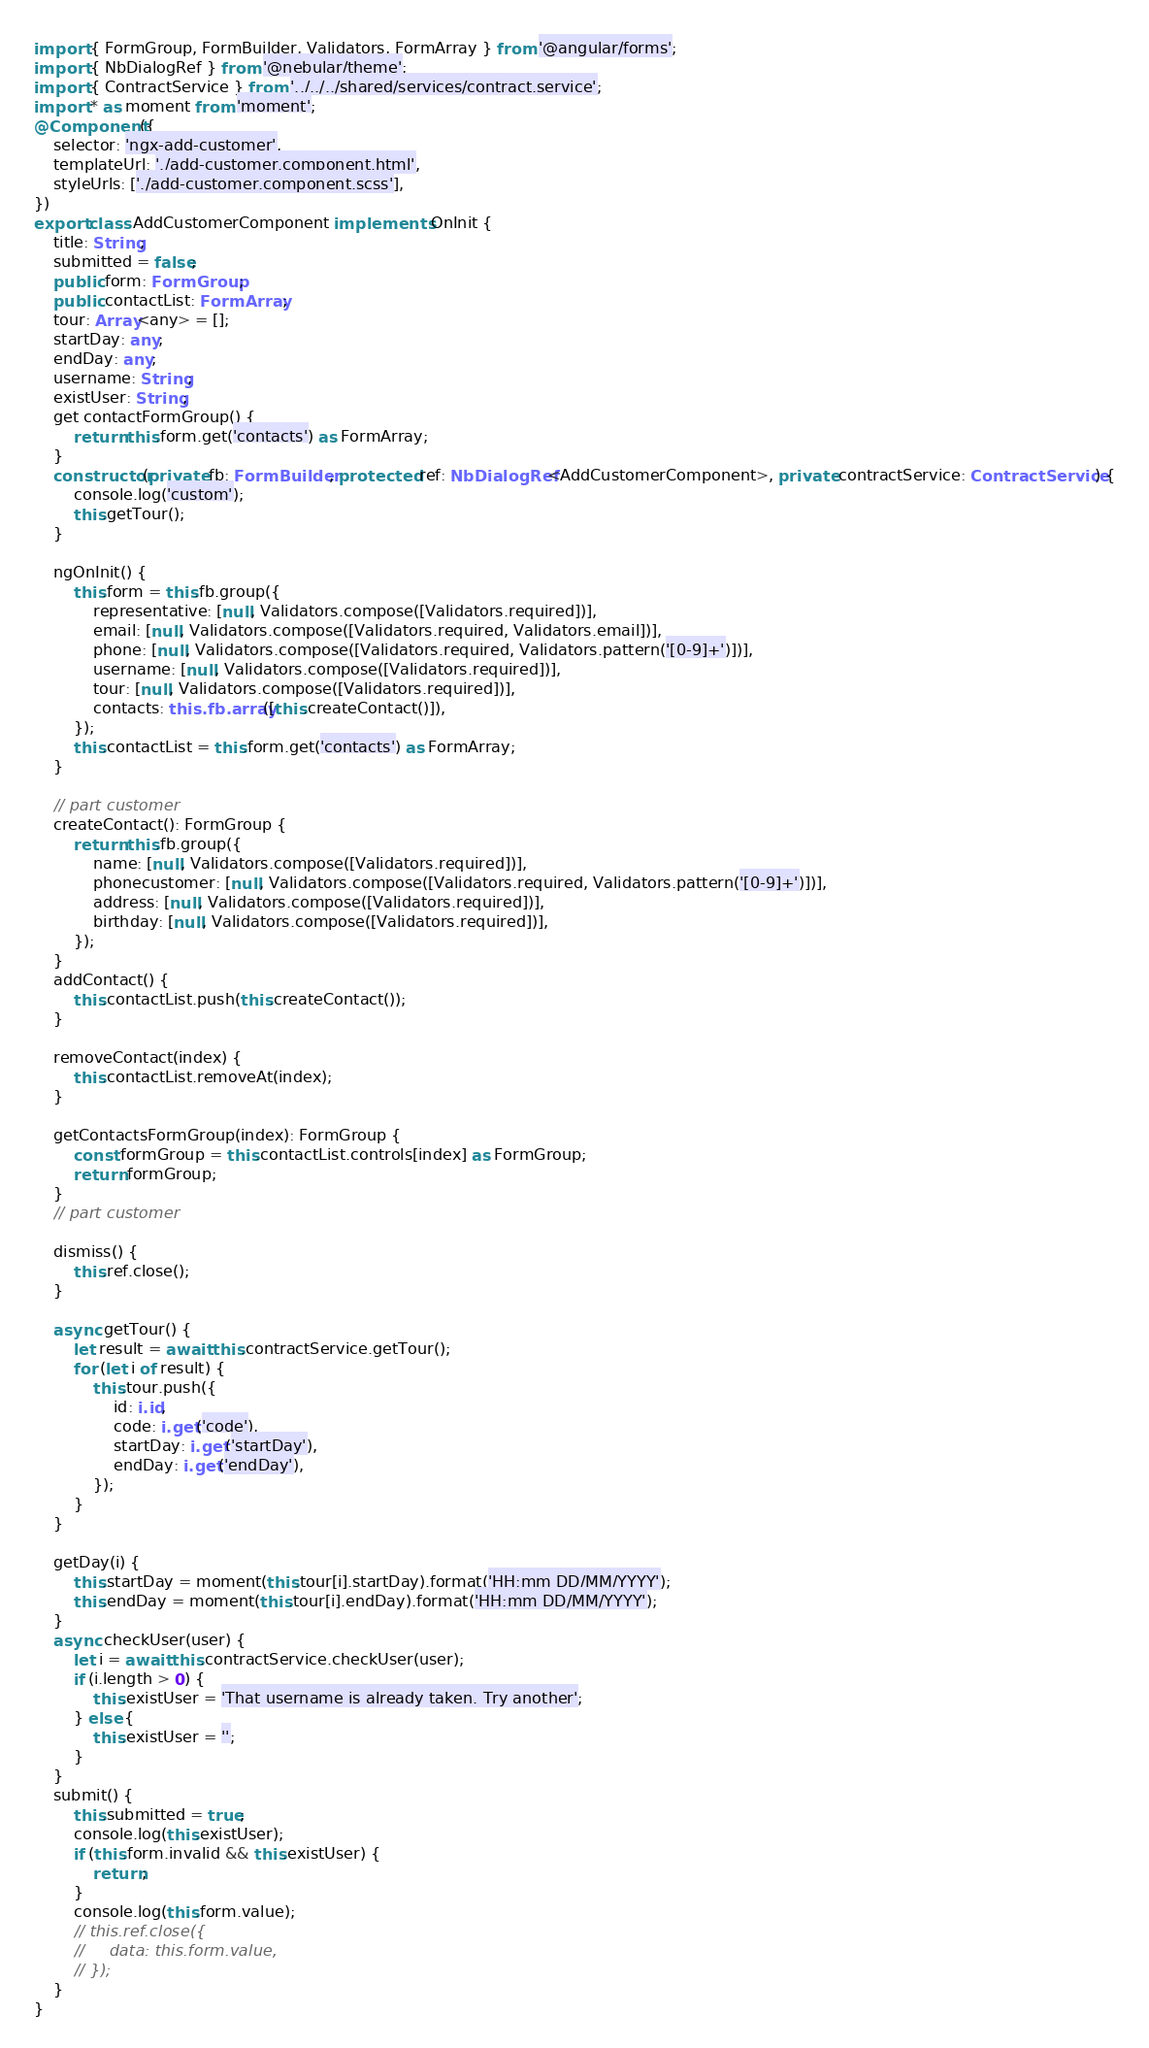<code> <loc_0><loc_0><loc_500><loc_500><_TypeScript_>import { FormGroup, FormBuilder, Validators, FormArray } from '@angular/forms';
import { NbDialogRef } from '@nebular/theme';
import { ContractService } from '../../../shared/services/contract.service';
import * as moment from 'moment';
@Component({
    selector: 'ngx-add-customer',
    templateUrl: './add-customer.component.html',
    styleUrls: ['./add-customer.component.scss'],
})
export class AddCustomerComponent implements OnInit {
    title: String;
    submitted = false;
    public form: FormGroup;
    public contactList: FormArray;
    tour: Array<any> = [];
    startDay: any;
    endDay: any;
    username: String;
    existUser: String;
    get contactFormGroup() {
        return this.form.get('contacts') as FormArray;
    }
    constructor(private fb: FormBuilder, protected ref: NbDialogRef<AddCustomerComponent>, private contractService: ContractService) {
        console.log('custom');
        this.getTour();
    }

    ngOnInit() {
        this.form = this.fb.group({
            representative: [null, Validators.compose([Validators.required])],
            email: [null, Validators.compose([Validators.required, Validators.email])],
            phone: [null, Validators.compose([Validators.required, Validators.pattern('[0-9]+')])],
            username: [null, Validators.compose([Validators.required])],
            tour: [null, Validators.compose([Validators.required])],
            contacts: this.fb.array([this.createContact()]),
        });
        this.contactList = this.form.get('contacts') as FormArray;
    }

    // part customer
    createContact(): FormGroup {
        return this.fb.group({
            name: [null, Validators.compose([Validators.required])],
            phonecustomer: [null, Validators.compose([Validators.required, Validators.pattern('[0-9]+')])],
            address: [null, Validators.compose([Validators.required])],
            birthday: [null, Validators.compose([Validators.required])],
        });
    }
    addContact() {
        this.contactList.push(this.createContact());
    }

    removeContact(index) {
        this.contactList.removeAt(index);
    }

    getContactsFormGroup(index): FormGroup {
        const formGroup = this.contactList.controls[index] as FormGroup;
        return formGroup;
    }
    // part customer

    dismiss() {
        this.ref.close();
    }

    async getTour() {
        let result = await this.contractService.getTour();
        for (let i of result) {
            this.tour.push({
                id: i.id,
                code: i.get('code'),
                startDay: i.get('startDay'),
                endDay: i.get('endDay'),
            });
        }
    }

    getDay(i) {
        this.startDay = moment(this.tour[i].startDay).format('HH:mm DD/MM/YYYY');
        this.endDay = moment(this.tour[i].endDay).format('HH:mm DD/MM/YYYY');
    }
    async checkUser(user) {
        let i = await this.contractService.checkUser(user);
        if (i.length > 0) {
            this.existUser = 'That username is already taken. Try another';
        } else {
            this.existUser = '';
        }
    }
    submit() {
        this.submitted = true;
        console.log(this.existUser);
        if (this.form.invalid && this.existUser) {
            return;
        }
        console.log(this.form.value);
        // this.ref.close({
        //     data: this.form.value,
        // });
    }
}
</code> 